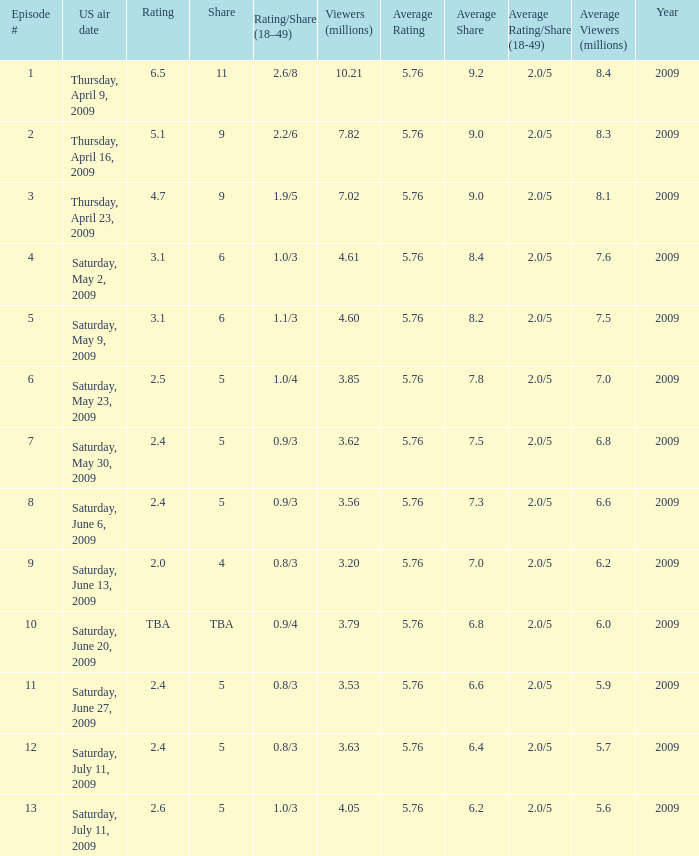What is the rating/share for episode 13? 1.0/3. 